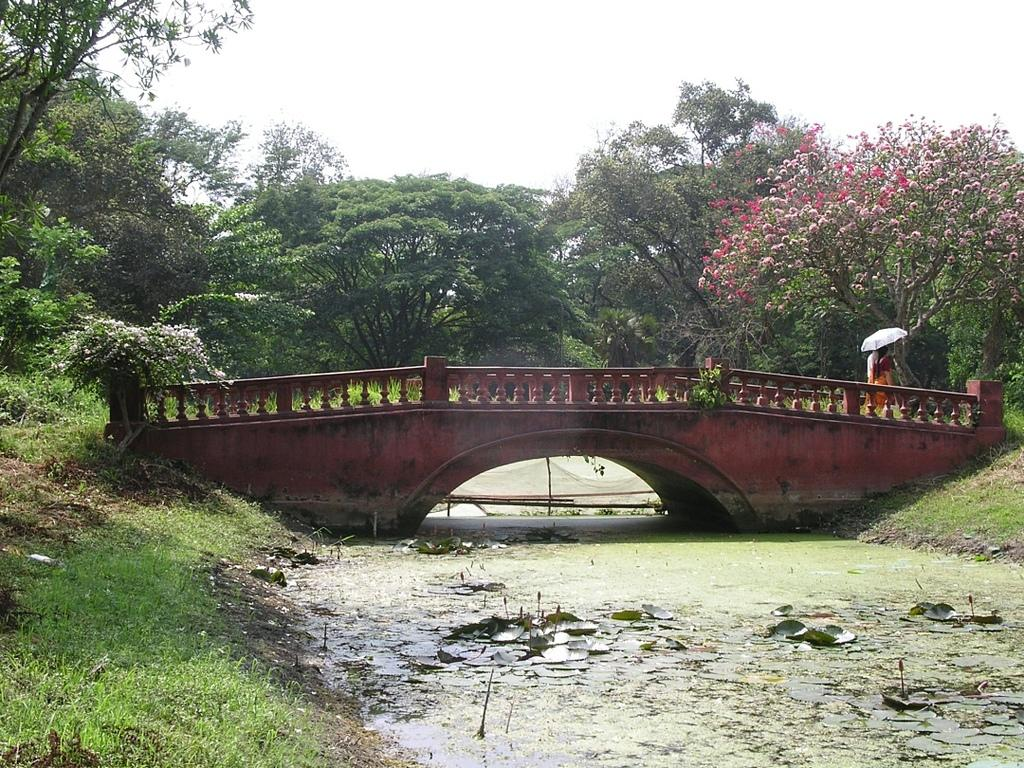How many people are in the image? There are two persons in the image. What are the persons doing in the image? The persons are walking on a bridge. What are the persons holding in the image? The persons are holding an umbrella. What type of vegetation can be seen in the image? There are plants, trees, flowers, and grass in the image. What body of water is visible in the image? There is a lake visible in the image. What part of the natural environment is visible in the image? The sky is visible in the image. What type of wood is used to construct the square recess in the image? There is no wood or square recess present in the image. 